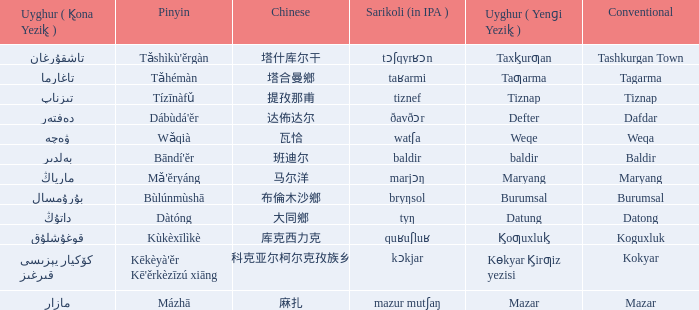Would you be able to parse every entry in this table? {'header': ['Uyghur ( K̢ona Yezik̢ )', 'Pinyin', 'Chinese', 'Sarikoli (in IPA )', 'Uyghur ( Yenɡi Yezik̢ )', 'Conventional'], 'rows': [['تاشقۇرغان', "Tǎshìkù'ěrgàn", '塔什库尔干', 'tɔʃqyrʁɔn', 'Taxk̡urƣan', 'Tashkurgan Town'], ['تاغارما', 'Tǎhémàn', '塔合曼鄉', 'taʁarmi', 'Taƣarma', 'Tagarma'], ['تىزناپ', 'Tízīnàfǔ', '提孜那甫', 'tiznef', 'Tiznap', 'Tiznap'], ['دەفتەر', "Dábùdá'ĕr", '达佈达尔', 'ðavðɔr', 'Defter', 'Dafdar'], ['ۋەچە', 'Wǎqià', '瓦恰', 'watʃa', 'Weqe', 'Weqa'], ['بەلدىر', "Bāndí'ĕr", '班迪尔', 'baldir', 'baldir', 'Baldir'], ['مارياڭ', "Mǎ'ĕryáng", '马尔洋', 'marjɔŋ', 'Maryang', 'Maryang'], ['بۇرۇمسال', 'Bùlúnmùshā', '布倫木沙鄉', 'bryŋsol', 'Burumsal', 'Burumsal'], ['داتۇڭ', 'Dàtóng', '大同鄉', 'tyŋ', 'Datung', 'Datong'], ['قوغۇشلۇق', 'Kùkèxīlìkè', '库克西力克', 'quʁuʃluʁ', 'K̡oƣuxluk̡', 'Koguxluk'], ['كۆكيار قىرغىز يېزىسى', "Kēkèyà'ěr Kē'ěrkèzīzú xiāng", '科克亚尔柯尔克孜族乡', 'kɔkjar', 'Kɵkyar K̡irƣiz yezisi', 'Kokyar'], ['مازار', 'Mázhā', '麻扎', 'mazur mutʃaŋ', 'Mazar', 'Mazar']]} Name the uyghur for  瓦恰 ۋەچە. 